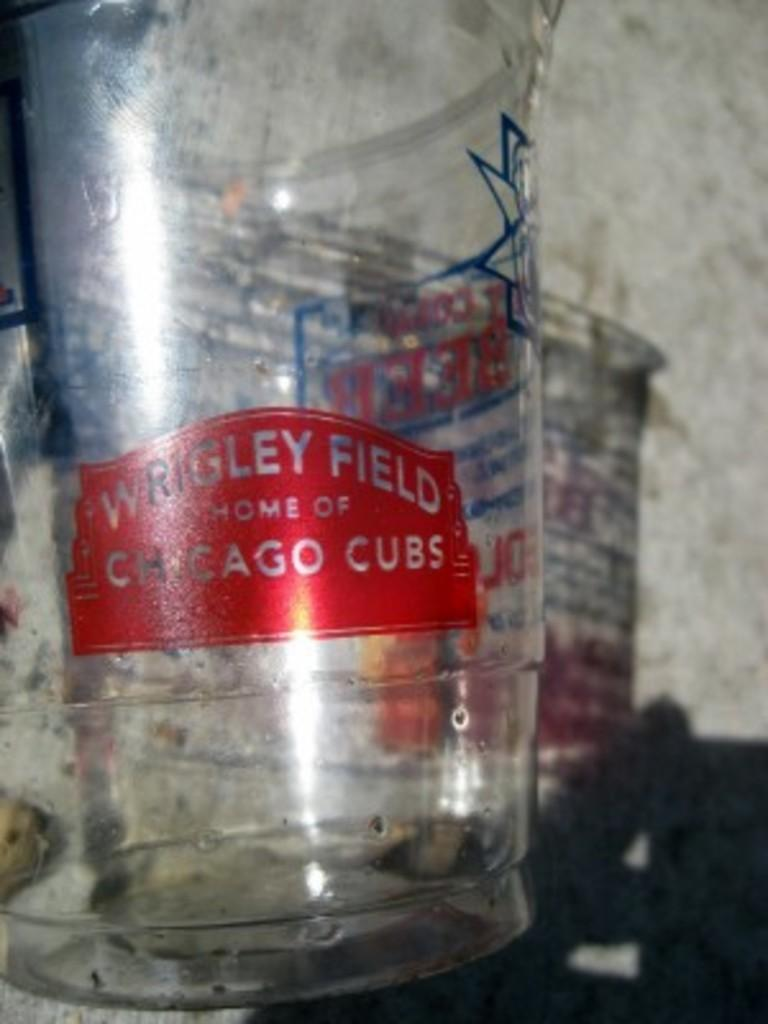<image>
Relay a brief, clear account of the picture shown. A plastic up that came from Wrigley Field in Chicago. 